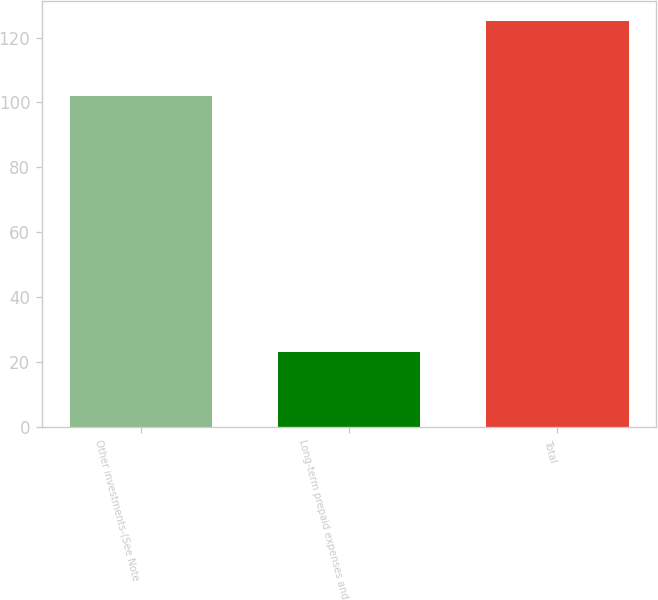<chart> <loc_0><loc_0><loc_500><loc_500><bar_chart><fcel>Other investments-(See Note<fcel>Long-term prepaid expenses and<fcel>Total<nl><fcel>102<fcel>23<fcel>125<nl></chart> 